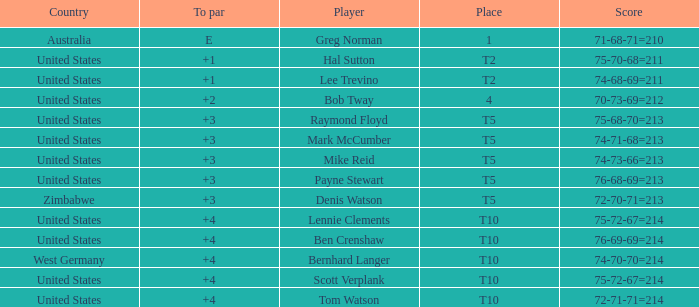Who is the player with a 75-68-70=213 score? Raymond Floyd. 